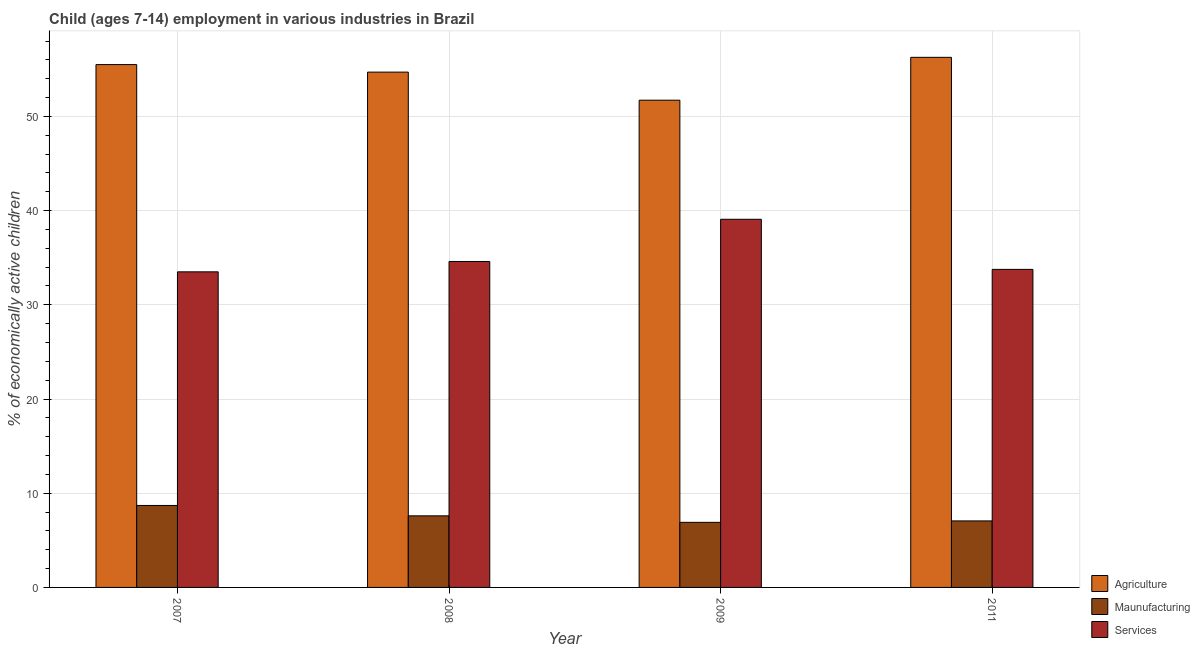Are the number of bars per tick equal to the number of legend labels?
Make the answer very short. Yes. Are the number of bars on each tick of the X-axis equal?
Your response must be concise. Yes. How many bars are there on the 1st tick from the right?
Your answer should be very brief. 3. What is the label of the 1st group of bars from the left?
Your answer should be compact. 2007. In how many cases, is the number of bars for a given year not equal to the number of legend labels?
Give a very brief answer. 0. What is the percentage of economically active children in agriculture in 2008?
Keep it short and to the point. 54.7. Across all years, what is the minimum percentage of economically active children in agriculture?
Your response must be concise. 51.72. In which year was the percentage of economically active children in services maximum?
Keep it short and to the point. 2009. What is the total percentage of economically active children in services in the graph?
Your answer should be compact. 140.94. What is the difference between the percentage of economically active children in manufacturing in 2007 and that in 2011?
Your answer should be compact. 1.64. What is the difference between the percentage of economically active children in services in 2007 and the percentage of economically active children in manufacturing in 2009?
Ensure brevity in your answer.  -5.58. What is the average percentage of economically active children in services per year?
Your answer should be very brief. 35.23. What is the ratio of the percentage of economically active children in manufacturing in 2007 to that in 2008?
Your answer should be compact. 1.14. What is the difference between the highest and the second highest percentage of economically active children in agriculture?
Your answer should be very brief. 0.77. What is the difference between the highest and the lowest percentage of economically active children in agriculture?
Ensure brevity in your answer.  4.55. What does the 3rd bar from the left in 2008 represents?
Your answer should be very brief. Services. What does the 2nd bar from the right in 2011 represents?
Your answer should be very brief. Maunufacturing. What is the difference between two consecutive major ticks on the Y-axis?
Keep it short and to the point. 10. Does the graph contain any zero values?
Keep it short and to the point. No. What is the title of the graph?
Ensure brevity in your answer.  Child (ages 7-14) employment in various industries in Brazil. What is the label or title of the X-axis?
Your response must be concise. Year. What is the label or title of the Y-axis?
Your answer should be very brief. % of economically active children. What is the % of economically active children in Agriculture in 2007?
Your answer should be very brief. 55.5. What is the % of economically active children in Services in 2007?
Your answer should be very brief. 33.5. What is the % of economically active children of Agriculture in 2008?
Make the answer very short. 54.7. What is the % of economically active children of Services in 2008?
Your answer should be compact. 34.6. What is the % of economically active children of Agriculture in 2009?
Offer a very short reply. 51.72. What is the % of economically active children in Maunufacturing in 2009?
Offer a terse response. 6.91. What is the % of economically active children in Services in 2009?
Your answer should be compact. 39.08. What is the % of economically active children in Agriculture in 2011?
Your answer should be very brief. 56.27. What is the % of economically active children in Maunufacturing in 2011?
Offer a terse response. 7.06. What is the % of economically active children of Services in 2011?
Your response must be concise. 33.76. Across all years, what is the maximum % of economically active children in Agriculture?
Your response must be concise. 56.27. Across all years, what is the maximum % of economically active children of Services?
Keep it short and to the point. 39.08. Across all years, what is the minimum % of economically active children of Agriculture?
Ensure brevity in your answer.  51.72. Across all years, what is the minimum % of economically active children of Maunufacturing?
Provide a succinct answer. 6.91. Across all years, what is the minimum % of economically active children of Services?
Make the answer very short. 33.5. What is the total % of economically active children of Agriculture in the graph?
Give a very brief answer. 218.19. What is the total % of economically active children of Maunufacturing in the graph?
Keep it short and to the point. 30.27. What is the total % of economically active children of Services in the graph?
Your answer should be very brief. 140.94. What is the difference between the % of economically active children in Agriculture in 2007 and that in 2009?
Offer a very short reply. 3.78. What is the difference between the % of economically active children of Maunufacturing in 2007 and that in 2009?
Give a very brief answer. 1.79. What is the difference between the % of economically active children of Services in 2007 and that in 2009?
Offer a terse response. -5.58. What is the difference between the % of economically active children in Agriculture in 2007 and that in 2011?
Give a very brief answer. -0.77. What is the difference between the % of economically active children in Maunufacturing in 2007 and that in 2011?
Your answer should be very brief. 1.64. What is the difference between the % of economically active children of Services in 2007 and that in 2011?
Provide a short and direct response. -0.26. What is the difference between the % of economically active children in Agriculture in 2008 and that in 2009?
Your answer should be very brief. 2.98. What is the difference between the % of economically active children of Maunufacturing in 2008 and that in 2009?
Make the answer very short. 0.69. What is the difference between the % of economically active children in Services in 2008 and that in 2009?
Offer a very short reply. -4.48. What is the difference between the % of economically active children in Agriculture in 2008 and that in 2011?
Offer a terse response. -1.57. What is the difference between the % of economically active children of Maunufacturing in 2008 and that in 2011?
Keep it short and to the point. 0.54. What is the difference between the % of economically active children of Services in 2008 and that in 2011?
Your answer should be compact. 0.84. What is the difference between the % of economically active children of Agriculture in 2009 and that in 2011?
Keep it short and to the point. -4.55. What is the difference between the % of economically active children of Maunufacturing in 2009 and that in 2011?
Provide a short and direct response. -0.15. What is the difference between the % of economically active children of Services in 2009 and that in 2011?
Your response must be concise. 5.32. What is the difference between the % of economically active children of Agriculture in 2007 and the % of economically active children of Maunufacturing in 2008?
Keep it short and to the point. 47.9. What is the difference between the % of economically active children in Agriculture in 2007 and the % of economically active children in Services in 2008?
Offer a very short reply. 20.9. What is the difference between the % of economically active children of Maunufacturing in 2007 and the % of economically active children of Services in 2008?
Provide a short and direct response. -25.9. What is the difference between the % of economically active children in Agriculture in 2007 and the % of economically active children in Maunufacturing in 2009?
Offer a very short reply. 48.59. What is the difference between the % of economically active children of Agriculture in 2007 and the % of economically active children of Services in 2009?
Make the answer very short. 16.42. What is the difference between the % of economically active children in Maunufacturing in 2007 and the % of economically active children in Services in 2009?
Offer a very short reply. -30.38. What is the difference between the % of economically active children of Agriculture in 2007 and the % of economically active children of Maunufacturing in 2011?
Provide a short and direct response. 48.44. What is the difference between the % of economically active children in Agriculture in 2007 and the % of economically active children in Services in 2011?
Your answer should be very brief. 21.74. What is the difference between the % of economically active children in Maunufacturing in 2007 and the % of economically active children in Services in 2011?
Your response must be concise. -25.06. What is the difference between the % of economically active children of Agriculture in 2008 and the % of economically active children of Maunufacturing in 2009?
Ensure brevity in your answer.  47.79. What is the difference between the % of economically active children in Agriculture in 2008 and the % of economically active children in Services in 2009?
Offer a terse response. 15.62. What is the difference between the % of economically active children in Maunufacturing in 2008 and the % of economically active children in Services in 2009?
Make the answer very short. -31.48. What is the difference between the % of economically active children in Agriculture in 2008 and the % of economically active children in Maunufacturing in 2011?
Keep it short and to the point. 47.64. What is the difference between the % of economically active children in Agriculture in 2008 and the % of economically active children in Services in 2011?
Provide a succinct answer. 20.94. What is the difference between the % of economically active children in Maunufacturing in 2008 and the % of economically active children in Services in 2011?
Provide a short and direct response. -26.16. What is the difference between the % of economically active children of Agriculture in 2009 and the % of economically active children of Maunufacturing in 2011?
Give a very brief answer. 44.66. What is the difference between the % of economically active children of Agriculture in 2009 and the % of economically active children of Services in 2011?
Provide a succinct answer. 17.96. What is the difference between the % of economically active children of Maunufacturing in 2009 and the % of economically active children of Services in 2011?
Offer a terse response. -26.85. What is the average % of economically active children in Agriculture per year?
Your response must be concise. 54.55. What is the average % of economically active children in Maunufacturing per year?
Offer a very short reply. 7.57. What is the average % of economically active children in Services per year?
Offer a very short reply. 35.23. In the year 2007, what is the difference between the % of economically active children in Agriculture and % of economically active children in Maunufacturing?
Your answer should be compact. 46.8. In the year 2007, what is the difference between the % of economically active children of Agriculture and % of economically active children of Services?
Give a very brief answer. 22. In the year 2007, what is the difference between the % of economically active children in Maunufacturing and % of economically active children in Services?
Provide a succinct answer. -24.8. In the year 2008, what is the difference between the % of economically active children in Agriculture and % of economically active children in Maunufacturing?
Ensure brevity in your answer.  47.1. In the year 2008, what is the difference between the % of economically active children of Agriculture and % of economically active children of Services?
Your answer should be very brief. 20.1. In the year 2009, what is the difference between the % of economically active children of Agriculture and % of economically active children of Maunufacturing?
Make the answer very short. 44.81. In the year 2009, what is the difference between the % of economically active children in Agriculture and % of economically active children in Services?
Keep it short and to the point. 12.64. In the year 2009, what is the difference between the % of economically active children of Maunufacturing and % of economically active children of Services?
Give a very brief answer. -32.17. In the year 2011, what is the difference between the % of economically active children of Agriculture and % of economically active children of Maunufacturing?
Your response must be concise. 49.21. In the year 2011, what is the difference between the % of economically active children of Agriculture and % of economically active children of Services?
Your response must be concise. 22.51. In the year 2011, what is the difference between the % of economically active children in Maunufacturing and % of economically active children in Services?
Your answer should be very brief. -26.7. What is the ratio of the % of economically active children of Agriculture in 2007 to that in 2008?
Offer a very short reply. 1.01. What is the ratio of the % of economically active children of Maunufacturing in 2007 to that in 2008?
Your answer should be very brief. 1.14. What is the ratio of the % of economically active children in Services in 2007 to that in 2008?
Your answer should be compact. 0.97. What is the ratio of the % of economically active children of Agriculture in 2007 to that in 2009?
Your answer should be compact. 1.07. What is the ratio of the % of economically active children in Maunufacturing in 2007 to that in 2009?
Your response must be concise. 1.26. What is the ratio of the % of economically active children in Services in 2007 to that in 2009?
Your answer should be very brief. 0.86. What is the ratio of the % of economically active children of Agriculture in 2007 to that in 2011?
Your response must be concise. 0.99. What is the ratio of the % of economically active children of Maunufacturing in 2007 to that in 2011?
Provide a succinct answer. 1.23. What is the ratio of the % of economically active children of Services in 2007 to that in 2011?
Give a very brief answer. 0.99. What is the ratio of the % of economically active children in Agriculture in 2008 to that in 2009?
Give a very brief answer. 1.06. What is the ratio of the % of economically active children of Maunufacturing in 2008 to that in 2009?
Give a very brief answer. 1.1. What is the ratio of the % of economically active children in Services in 2008 to that in 2009?
Your response must be concise. 0.89. What is the ratio of the % of economically active children in Agriculture in 2008 to that in 2011?
Make the answer very short. 0.97. What is the ratio of the % of economically active children of Maunufacturing in 2008 to that in 2011?
Offer a very short reply. 1.08. What is the ratio of the % of economically active children of Services in 2008 to that in 2011?
Provide a short and direct response. 1.02. What is the ratio of the % of economically active children of Agriculture in 2009 to that in 2011?
Your answer should be compact. 0.92. What is the ratio of the % of economically active children of Maunufacturing in 2009 to that in 2011?
Offer a terse response. 0.98. What is the ratio of the % of economically active children of Services in 2009 to that in 2011?
Offer a terse response. 1.16. What is the difference between the highest and the second highest % of economically active children in Agriculture?
Offer a terse response. 0.77. What is the difference between the highest and the second highest % of economically active children in Services?
Your answer should be very brief. 4.48. What is the difference between the highest and the lowest % of economically active children in Agriculture?
Provide a short and direct response. 4.55. What is the difference between the highest and the lowest % of economically active children in Maunufacturing?
Offer a very short reply. 1.79. What is the difference between the highest and the lowest % of economically active children of Services?
Ensure brevity in your answer.  5.58. 